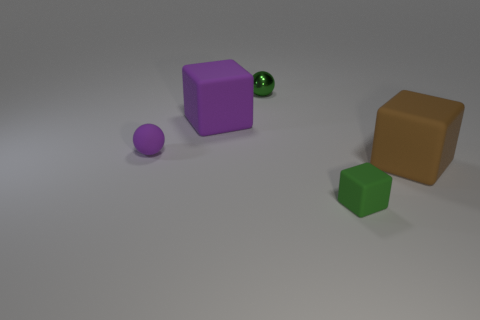Are the big thing that is on the left side of the tiny green block and the brown block made of the same material?
Your answer should be very brief. Yes. Is the number of big brown rubber objects that are behind the small green metal object less than the number of big brown rubber cubes that are on the left side of the large purple rubber thing?
Your response must be concise. No. There is a tiny block that is the same color as the small metal thing; what is it made of?
Make the answer very short. Rubber. There is a large rubber block that is to the left of the big rubber thing that is in front of the purple rubber cube; how many tiny metallic balls are on the right side of it?
Ensure brevity in your answer.  1. There is a metal thing; how many tiny metal objects are left of it?
Offer a terse response. 0. What number of brown objects have the same material as the green cube?
Give a very brief answer. 1. The other big cube that is the same material as the large brown block is what color?
Offer a very short reply. Purple. What material is the tiny sphere behind the rubber block behind the tiny sphere that is in front of the purple cube?
Provide a short and direct response. Metal. Is the size of the green thing in front of the green metal ball the same as the big purple cube?
Give a very brief answer. No. What number of tiny objects are either green shiny spheres or cyan metallic blocks?
Your response must be concise. 1. 